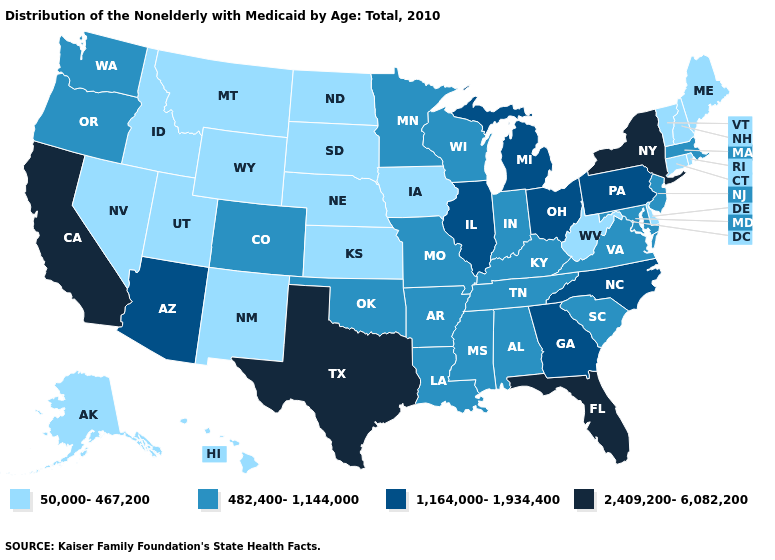What is the lowest value in the South?
Keep it brief. 50,000-467,200. Which states have the lowest value in the Northeast?
Quick response, please. Connecticut, Maine, New Hampshire, Rhode Island, Vermont. Name the states that have a value in the range 2,409,200-6,082,200?
Give a very brief answer. California, Florida, New York, Texas. Which states have the lowest value in the USA?
Give a very brief answer. Alaska, Connecticut, Delaware, Hawaii, Idaho, Iowa, Kansas, Maine, Montana, Nebraska, Nevada, New Hampshire, New Mexico, North Dakota, Rhode Island, South Dakota, Utah, Vermont, West Virginia, Wyoming. What is the value of Delaware?
Give a very brief answer. 50,000-467,200. Among the states that border Montana , which have the lowest value?
Short answer required. Idaho, North Dakota, South Dakota, Wyoming. How many symbols are there in the legend?
Be succinct. 4. Does the first symbol in the legend represent the smallest category?
Give a very brief answer. Yes. Name the states that have a value in the range 482,400-1,144,000?
Answer briefly. Alabama, Arkansas, Colorado, Indiana, Kentucky, Louisiana, Maryland, Massachusetts, Minnesota, Mississippi, Missouri, New Jersey, Oklahoma, Oregon, South Carolina, Tennessee, Virginia, Washington, Wisconsin. What is the value of South Carolina?
Concise answer only. 482,400-1,144,000. Does the map have missing data?
Give a very brief answer. No. Is the legend a continuous bar?
Be succinct. No. Which states have the highest value in the USA?
Keep it brief. California, Florida, New York, Texas. What is the value of Pennsylvania?
Quick response, please. 1,164,000-1,934,400. Does South Carolina have the lowest value in the USA?
Short answer required. No. 